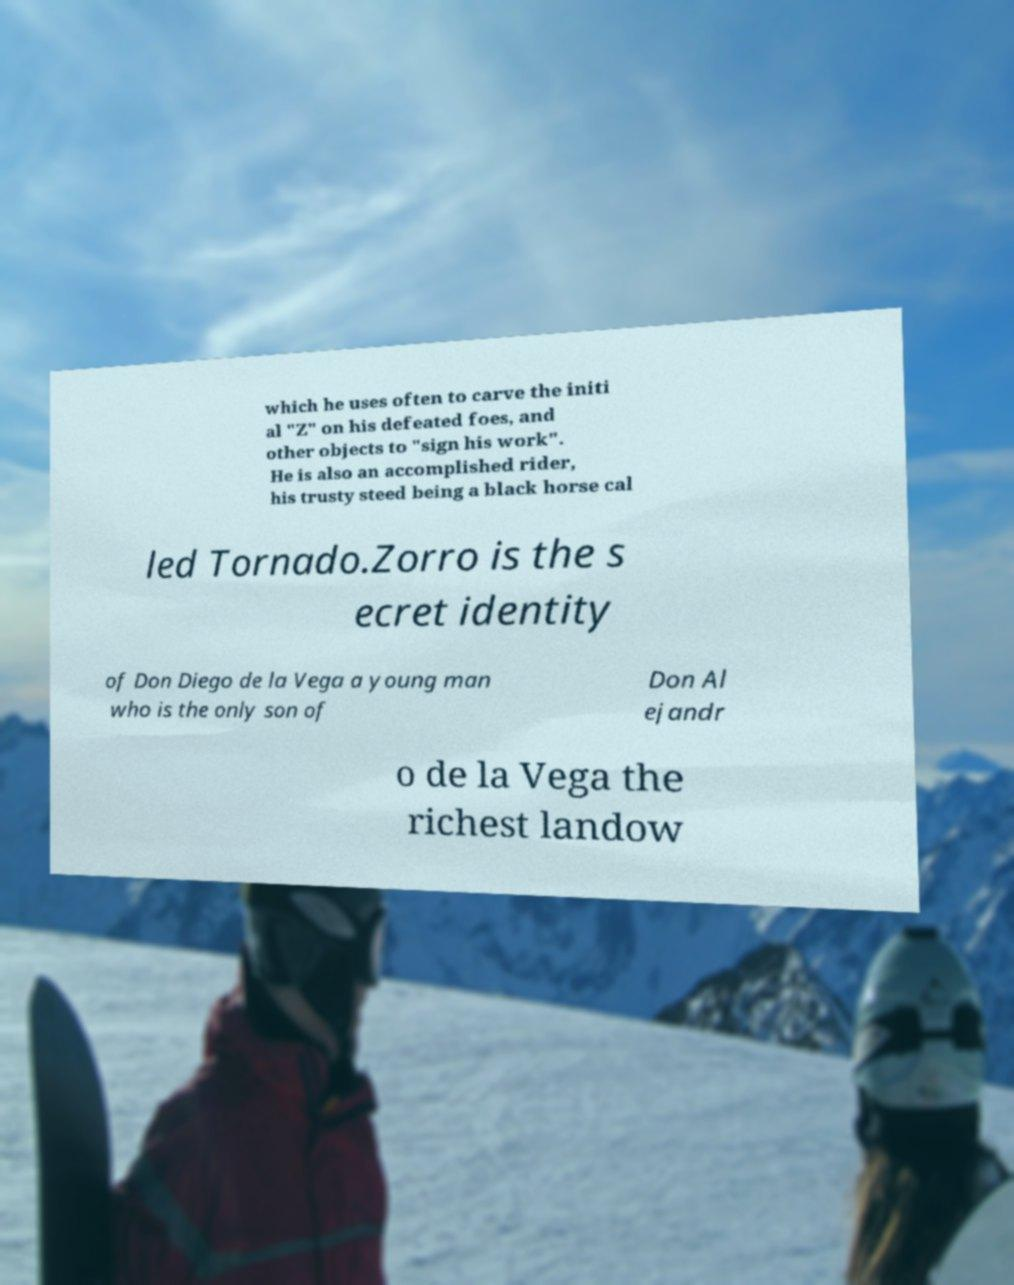Please identify and transcribe the text found in this image. which he uses often to carve the initi al "Z" on his defeated foes, and other objects to "sign his work". He is also an accomplished rider, his trusty steed being a black horse cal led Tornado.Zorro is the s ecret identity of Don Diego de la Vega a young man who is the only son of Don Al ejandr o de la Vega the richest landow 